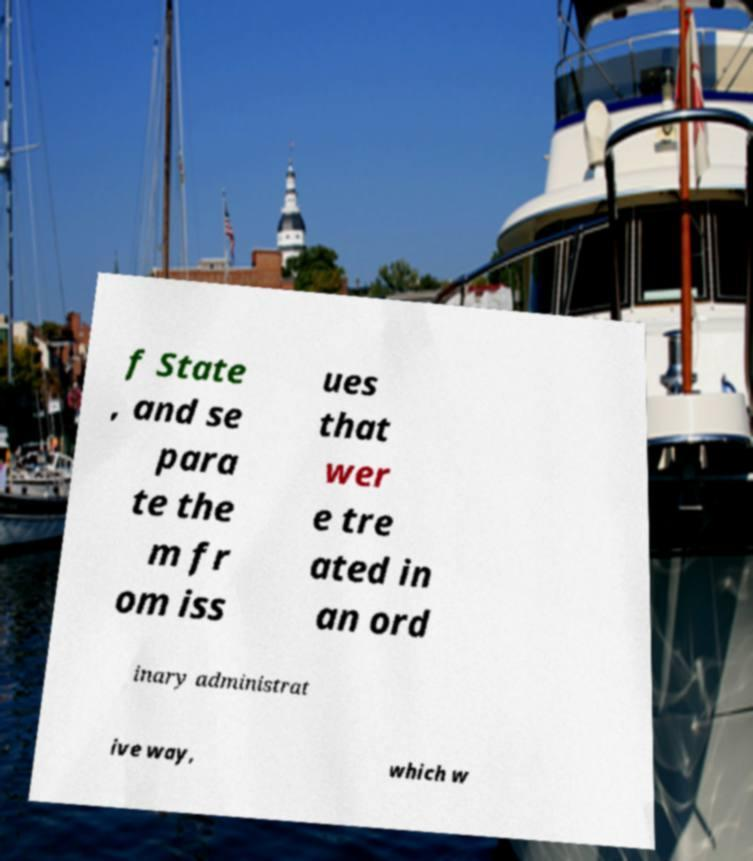I need the written content from this picture converted into text. Can you do that? f State , and se para te the m fr om iss ues that wer e tre ated in an ord inary administrat ive way, which w 